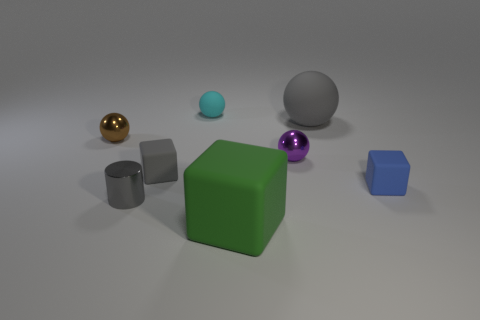Subtract all tiny matte cubes. How many cubes are left? 1 Add 1 gray rubber spheres. How many objects exist? 9 Subtract all gray cubes. How many cubes are left? 2 Subtract 3 spheres. How many spheres are left? 1 Subtract all green cubes. How many cyan spheres are left? 1 Subtract all tiny yellow objects. Subtract all blue rubber blocks. How many objects are left? 7 Add 1 gray rubber spheres. How many gray rubber spheres are left? 2 Add 1 tiny purple cylinders. How many tiny purple cylinders exist? 1 Subtract 1 gray balls. How many objects are left? 7 Subtract all cubes. How many objects are left? 5 